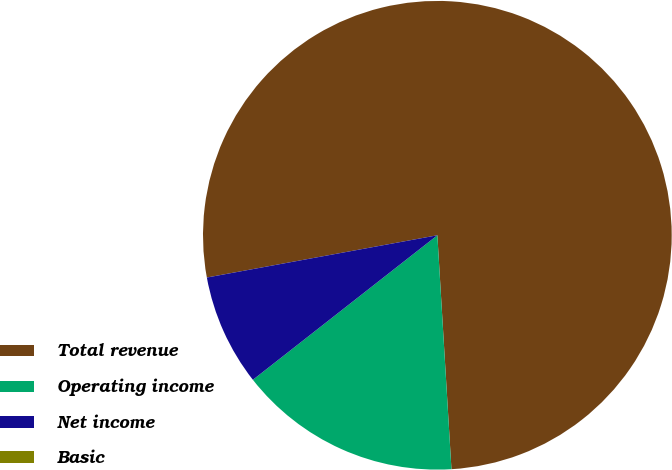<chart> <loc_0><loc_0><loc_500><loc_500><pie_chart><fcel>Total revenue<fcel>Operating income<fcel>Net income<fcel>Basic<nl><fcel>76.92%<fcel>15.38%<fcel>7.69%<fcel>0.0%<nl></chart> 